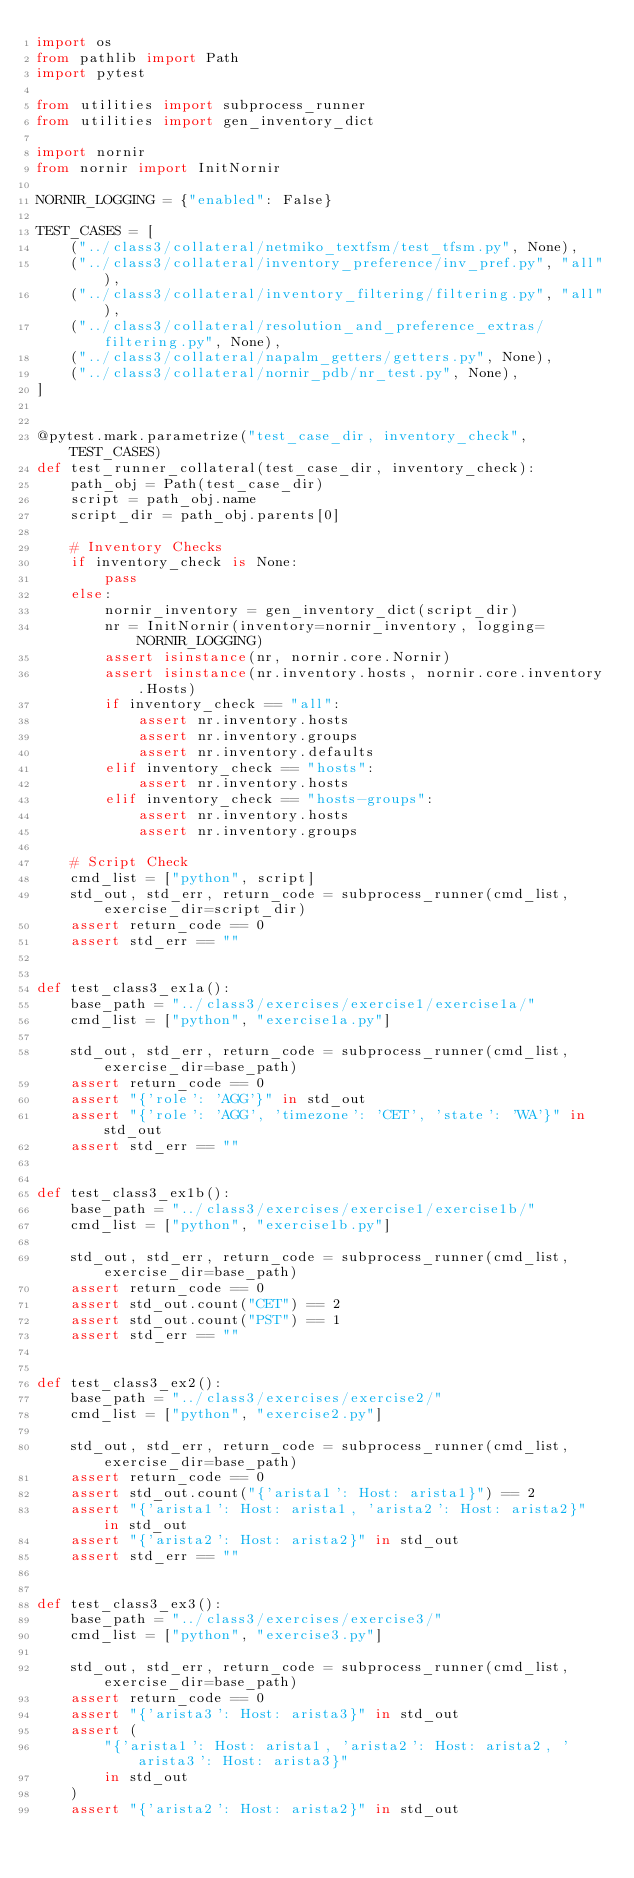Convert code to text. <code><loc_0><loc_0><loc_500><loc_500><_Python_>import os
from pathlib import Path
import pytest

from utilities import subprocess_runner
from utilities import gen_inventory_dict

import nornir
from nornir import InitNornir

NORNIR_LOGGING = {"enabled": False}

TEST_CASES = [
    ("../class3/collateral/netmiko_textfsm/test_tfsm.py", None),
    ("../class3/collateral/inventory_preference/inv_pref.py", "all"),
    ("../class3/collateral/inventory_filtering/filtering.py", "all"),
    ("../class3/collateral/resolution_and_preference_extras/filtering.py", None),
    ("../class3/collateral/napalm_getters/getters.py", None),
    ("../class3/collateral/nornir_pdb/nr_test.py", None),
]


@pytest.mark.parametrize("test_case_dir, inventory_check", TEST_CASES)
def test_runner_collateral(test_case_dir, inventory_check):
    path_obj = Path(test_case_dir)
    script = path_obj.name
    script_dir = path_obj.parents[0]

    # Inventory Checks
    if inventory_check is None:
        pass
    else:
        nornir_inventory = gen_inventory_dict(script_dir)
        nr = InitNornir(inventory=nornir_inventory, logging=NORNIR_LOGGING)
        assert isinstance(nr, nornir.core.Nornir)
        assert isinstance(nr.inventory.hosts, nornir.core.inventory.Hosts)
        if inventory_check == "all":
            assert nr.inventory.hosts
            assert nr.inventory.groups
            assert nr.inventory.defaults
        elif inventory_check == "hosts":
            assert nr.inventory.hosts
        elif inventory_check == "hosts-groups":
            assert nr.inventory.hosts
            assert nr.inventory.groups

    # Script Check
    cmd_list = ["python", script]
    std_out, std_err, return_code = subprocess_runner(cmd_list, exercise_dir=script_dir)
    assert return_code == 0
    assert std_err == ""


def test_class3_ex1a():
    base_path = "../class3/exercises/exercise1/exercise1a/"
    cmd_list = ["python", "exercise1a.py"]

    std_out, std_err, return_code = subprocess_runner(cmd_list, exercise_dir=base_path)
    assert return_code == 0
    assert "{'role': 'AGG'}" in std_out
    assert "{'role': 'AGG', 'timezone': 'CET', 'state': 'WA'}" in std_out
    assert std_err == ""


def test_class3_ex1b():
    base_path = "../class3/exercises/exercise1/exercise1b/"
    cmd_list = ["python", "exercise1b.py"]

    std_out, std_err, return_code = subprocess_runner(cmd_list, exercise_dir=base_path)
    assert return_code == 0
    assert std_out.count("CET") == 2
    assert std_out.count("PST") == 1
    assert std_err == ""


def test_class3_ex2():
    base_path = "../class3/exercises/exercise2/"
    cmd_list = ["python", "exercise2.py"]

    std_out, std_err, return_code = subprocess_runner(cmd_list, exercise_dir=base_path)
    assert return_code == 0
    assert std_out.count("{'arista1': Host: arista1}") == 2
    assert "{'arista1': Host: arista1, 'arista2': Host: arista2}" in std_out
    assert "{'arista2': Host: arista2}" in std_out
    assert std_err == ""


def test_class3_ex3():
    base_path = "../class3/exercises/exercise3/"
    cmd_list = ["python", "exercise3.py"]

    std_out, std_err, return_code = subprocess_runner(cmd_list, exercise_dir=base_path)
    assert return_code == 0
    assert "{'arista3': Host: arista3}" in std_out
    assert (
        "{'arista1': Host: arista1, 'arista2': Host: arista2, 'arista3': Host: arista3}"
        in std_out
    )
    assert "{'arista2': Host: arista2}" in std_out</code> 